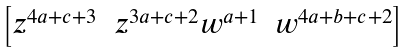<formula> <loc_0><loc_0><loc_500><loc_500>\begin{bmatrix} z ^ { 4 a + c + 3 } & z ^ { 3 a + c + 2 } w ^ { a + 1 } & w ^ { 4 a + b + c + 2 } \end{bmatrix}</formula> 